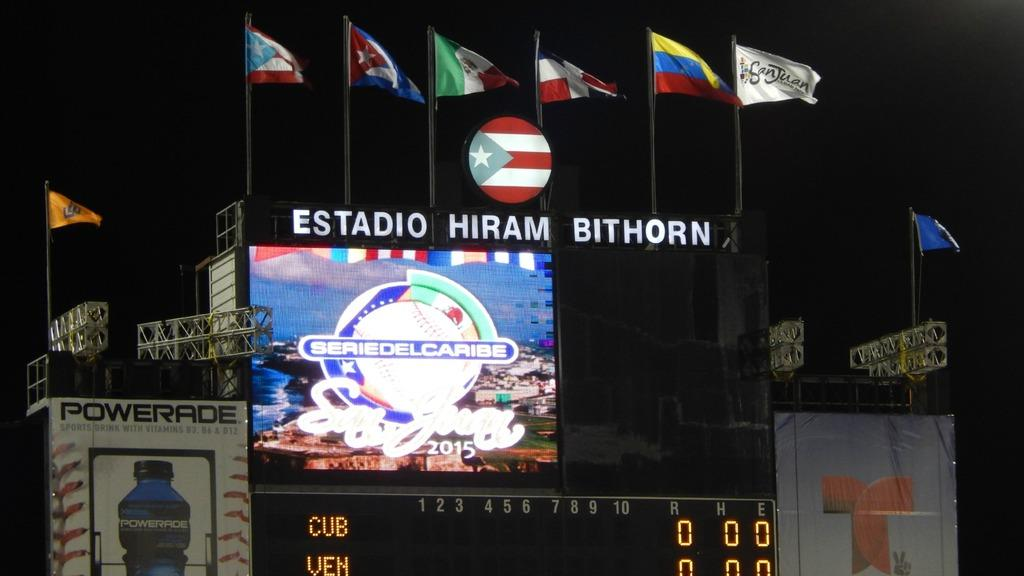<image>
Provide a brief description of the given image. Sports scoreboard with flags at the top and the words IO HIRAM BITHORN. 